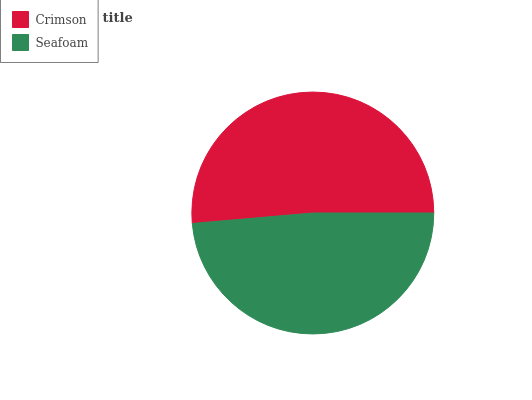Is Seafoam the minimum?
Answer yes or no. Yes. Is Crimson the maximum?
Answer yes or no. Yes. Is Seafoam the maximum?
Answer yes or no. No. Is Crimson greater than Seafoam?
Answer yes or no. Yes. Is Seafoam less than Crimson?
Answer yes or no. Yes. Is Seafoam greater than Crimson?
Answer yes or no. No. Is Crimson less than Seafoam?
Answer yes or no. No. Is Crimson the high median?
Answer yes or no. Yes. Is Seafoam the low median?
Answer yes or no. Yes. Is Seafoam the high median?
Answer yes or no. No. Is Crimson the low median?
Answer yes or no. No. 